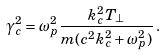<formula> <loc_0><loc_0><loc_500><loc_500>\gamma _ { c } ^ { 2 } = \omega _ { p } ^ { 2 } \frac { k _ { c } ^ { 2 } T _ { \bot } } { m ( c ^ { 2 } k _ { c } ^ { 2 } + \omega _ { p } ^ { 2 } ) } \, .</formula> 